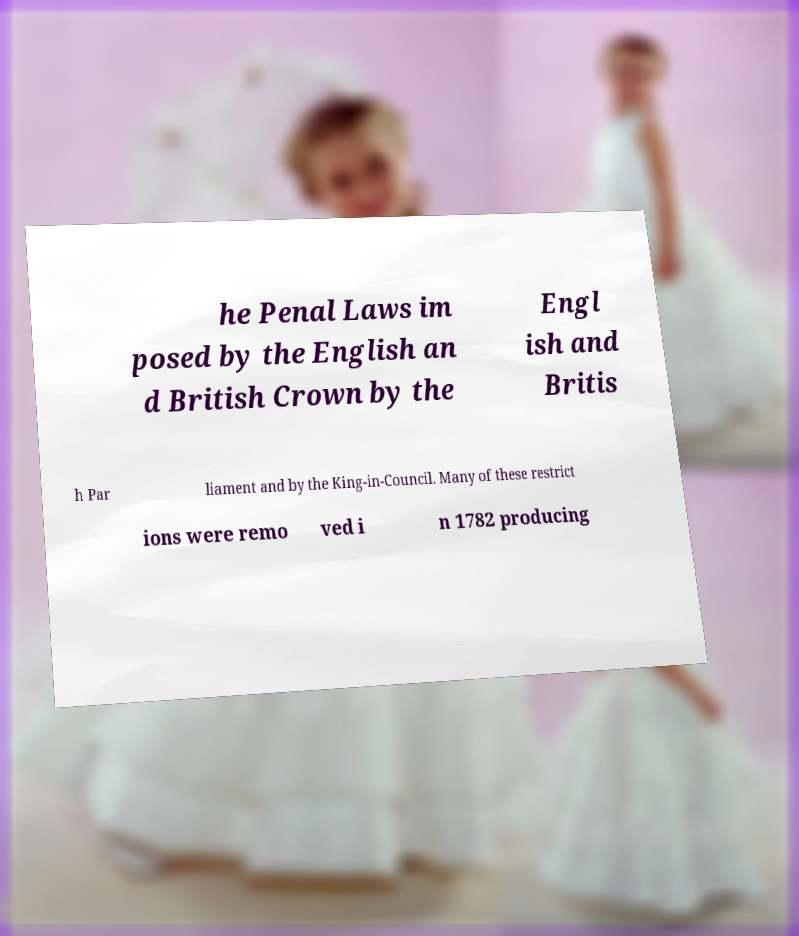Please read and relay the text visible in this image. What does it say? he Penal Laws im posed by the English an d British Crown by the Engl ish and Britis h Par liament and by the King-in-Council. Many of these restrict ions were remo ved i n 1782 producing 